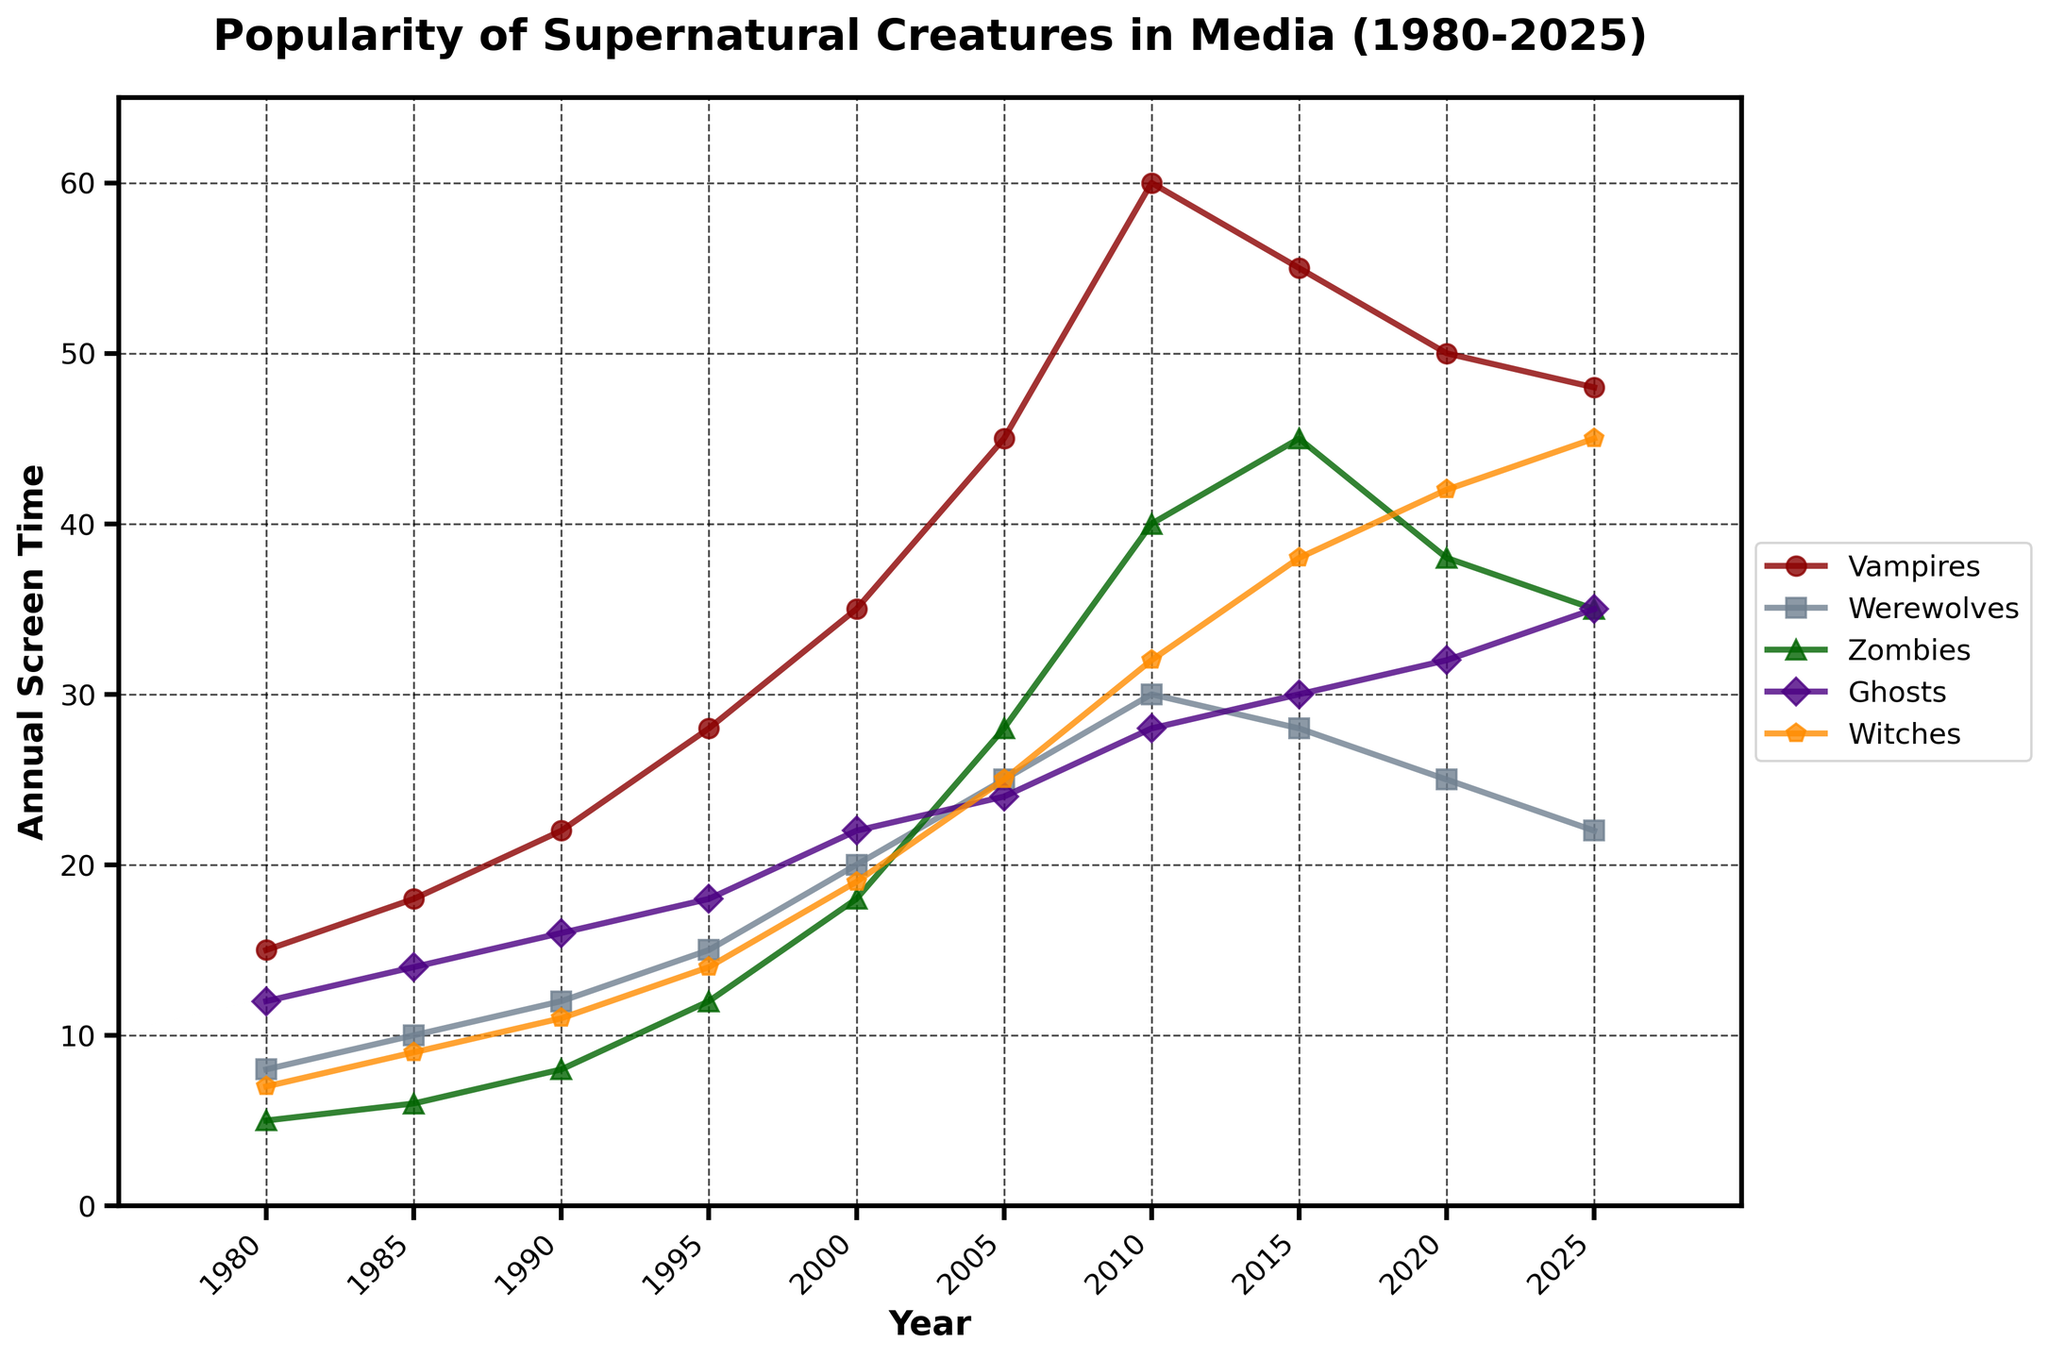What trend do Vampires show in annual screen time from 2000 to 2025? Observe the plotted line for Vampires. From 2000 to 2010, there is a rising trend from 35 to 60. After 2010, the popularity declines gradually to 48 by 2025.
Answer: Rising till 2010, then declining Which creature has the highest annual screen time in 2025? Look for the highest point on the graph in 2025. Witches have the highest value at 45.
Answer: Witches By how much did the annual screen time of Zombies change between 1990 and 2015? Calculate the difference in the annual screen time of Zombies from 1990 to 2015. In 1990, it is 8, and in 2015, it is 45. The change is 45 - 8 = 37.
Answer: 37 What is the overall trend for Witches from 1980 to 2025? Observe the plotted points for Witches. Witches' screen time rises consistently from 1980 to 2025, increasing from 7 to 45.
Answer: Increasing Which two creatures had similar annual screen time around 2015? Compare the 2015 values for each creature on the graph. Ghosts and Zombies have values close to each other, at 30 and 45 respectively. Although not exactly similar, these are the closest.
Answer: Ghosts and Zombies Between which years did Werewolves see the most significant increase in popularity? Look for the steepest segment in Werewolves' line. From 2000 to 2005, there is a significant increase from 20 to 25.
Answer: 2000 to 2005 Identify the periods where Ghosts' screen time showed stability. Observe flat segments in the Ghosts' line. From 2005 to 2010, it increases more slowly, and a similar slow increase is seen from 2020 to 2025.
Answer: 2005-2010, 2020-2025 Which creatures had a decline in screen time after reaching their peak according to the graph? Identify creatures reaching a high point and then declining. Vampires and Zombies show declines after their peak years.
Answer: Vampires and Zombies What was the screen time for Witches in 2000, and how did it change by 2025? Note the value for Witches in 2000, which is 19, and compare it to 2025, which is 45. The change is 45 - 19 = 26.
Answer: 26 